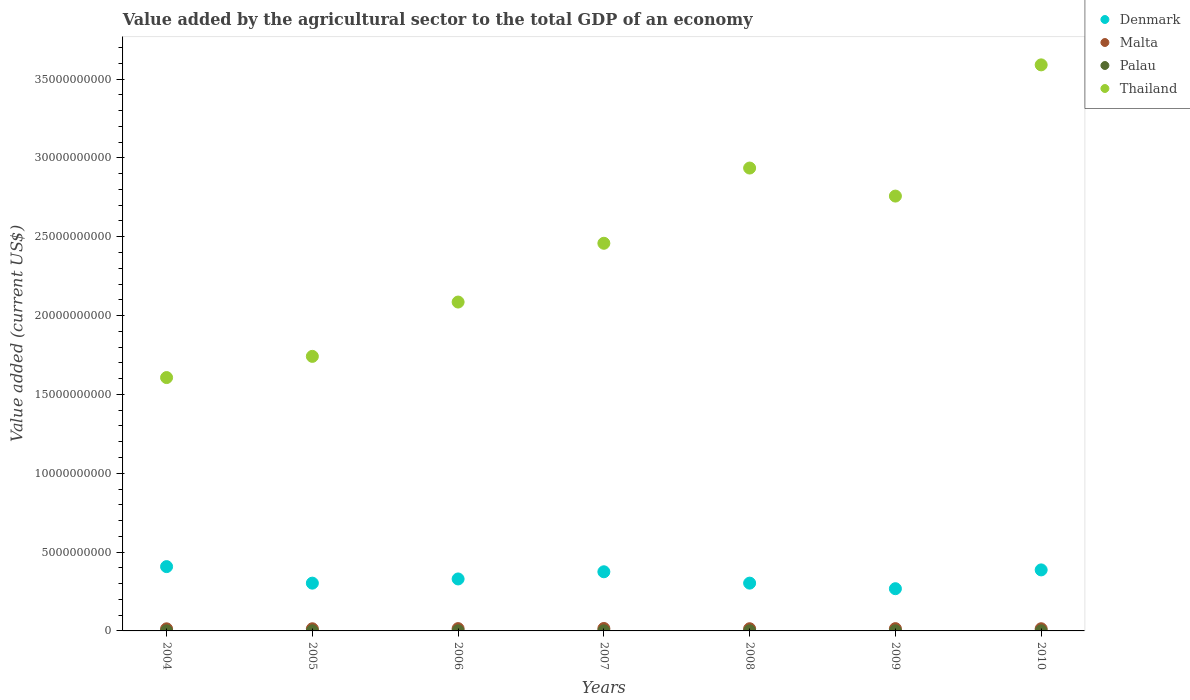How many different coloured dotlines are there?
Offer a very short reply. 4. Is the number of dotlines equal to the number of legend labels?
Your response must be concise. Yes. What is the value added by the agricultural sector to the total GDP in Palau in 2005?
Provide a short and direct response. 7.64e+06. Across all years, what is the maximum value added by the agricultural sector to the total GDP in Palau?
Your response must be concise. 8.54e+06. Across all years, what is the minimum value added by the agricultural sector to the total GDP in Denmark?
Offer a very short reply. 2.68e+09. In which year was the value added by the agricultural sector to the total GDP in Malta maximum?
Give a very brief answer. 2007. In which year was the value added by the agricultural sector to the total GDP in Palau minimum?
Ensure brevity in your answer.  2004. What is the total value added by the agricultural sector to the total GDP in Malta in the graph?
Offer a terse response. 9.92e+08. What is the difference between the value added by the agricultural sector to the total GDP in Palau in 2006 and that in 2008?
Offer a very short reply. 7.83e+04. What is the difference between the value added by the agricultural sector to the total GDP in Palau in 2006 and the value added by the agricultural sector to the total GDP in Denmark in 2010?
Your response must be concise. -3.86e+09. What is the average value added by the agricultural sector to the total GDP in Thailand per year?
Offer a very short reply. 2.45e+1. In the year 2005, what is the difference between the value added by the agricultural sector to the total GDP in Palau and value added by the agricultural sector to the total GDP in Denmark?
Provide a succinct answer. -3.02e+09. In how many years, is the value added by the agricultural sector to the total GDP in Palau greater than 34000000000 US$?
Keep it short and to the point. 0. What is the ratio of the value added by the agricultural sector to the total GDP in Thailand in 2006 to that in 2007?
Ensure brevity in your answer.  0.85. Is the value added by the agricultural sector to the total GDP in Denmark in 2007 less than that in 2009?
Make the answer very short. No. Is the difference between the value added by the agricultural sector to the total GDP in Palau in 2009 and 2010 greater than the difference between the value added by the agricultural sector to the total GDP in Denmark in 2009 and 2010?
Give a very brief answer. Yes. What is the difference between the highest and the second highest value added by the agricultural sector to the total GDP in Thailand?
Your answer should be compact. 6.54e+09. What is the difference between the highest and the lowest value added by the agricultural sector to the total GDP in Malta?
Your answer should be compact. 2.16e+07. In how many years, is the value added by the agricultural sector to the total GDP in Malta greater than the average value added by the agricultural sector to the total GDP in Malta taken over all years?
Provide a short and direct response. 3. Is the sum of the value added by the agricultural sector to the total GDP in Malta in 2006 and 2010 greater than the maximum value added by the agricultural sector to the total GDP in Thailand across all years?
Offer a terse response. No. Is it the case that in every year, the sum of the value added by the agricultural sector to the total GDP in Thailand and value added by the agricultural sector to the total GDP in Denmark  is greater than the sum of value added by the agricultural sector to the total GDP in Malta and value added by the agricultural sector to the total GDP in Palau?
Provide a succinct answer. Yes. Is the value added by the agricultural sector to the total GDP in Denmark strictly greater than the value added by the agricultural sector to the total GDP in Thailand over the years?
Your answer should be very brief. No. Is the value added by the agricultural sector to the total GDP in Malta strictly less than the value added by the agricultural sector to the total GDP in Palau over the years?
Offer a terse response. No. How many years are there in the graph?
Your response must be concise. 7. Are the values on the major ticks of Y-axis written in scientific E-notation?
Your answer should be compact. No. Does the graph contain any zero values?
Offer a terse response. No. How are the legend labels stacked?
Provide a short and direct response. Vertical. What is the title of the graph?
Provide a short and direct response. Value added by the agricultural sector to the total GDP of an economy. Does "Turkmenistan" appear as one of the legend labels in the graph?
Keep it short and to the point. No. What is the label or title of the Y-axis?
Ensure brevity in your answer.  Value added (current US$). What is the Value added (current US$) in Denmark in 2004?
Keep it short and to the point. 4.08e+09. What is the Value added (current US$) in Malta in 2004?
Your answer should be very brief. 1.33e+08. What is the Value added (current US$) of Palau in 2004?
Give a very brief answer. 6.77e+06. What is the Value added (current US$) of Thailand in 2004?
Provide a succinct answer. 1.61e+1. What is the Value added (current US$) in Denmark in 2005?
Offer a terse response. 3.03e+09. What is the Value added (current US$) of Malta in 2005?
Provide a succinct answer. 1.36e+08. What is the Value added (current US$) in Palau in 2005?
Make the answer very short. 7.64e+06. What is the Value added (current US$) in Thailand in 2005?
Provide a short and direct response. 1.74e+1. What is the Value added (current US$) of Denmark in 2006?
Ensure brevity in your answer.  3.30e+09. What is the Value added (current US$) in Malta in 2006?
Ensure brevity in your answer.  1.47e+08. What is the Value added (current US$) of Palau in 2006?
Offer a very short reply. 8.54e+06. What is the Value added (current US$) in Thailand in 2006?
Provide a succinct answer. 2.09e+1. What is the Value added (current US$) of Denmark in 2007?
Your response must be concise. 3.75e+09. What is the Value added (current US$) of Malta in 2007?
Provide a succinct answer. 1.55e+08. What is the Value added (current US$) of Palau in 2007?
Offer a very short reply. 7.87e+06. What is the Value added (current US$) of Thailand in 2007?
Your response must be concise. 2.46e+1. What is the Value added (current US$) of Denmark in 2008?
Offer a very short reply. 3.03e+09. What is the Value added (current US$) in Malta in 2008?
Your answer should be compact. 1.39e+08. What is the Value added (current US$) in Palau in 2008?
Offer a very short reply. 8.46e+06. What is the Value added (current US$) of Thailand in 2008?
Provide a short and direct response. 2.94e+1. What is the Value added (current US$) of Denmark in 2009?
Keep it short and to the point. 2.68e+09. What is the Value added (current US$) in Malta in 2009?
Provide a short and direct response. 1.45e+08. What is the Value added (current US$) in Palau in 2009?
Your answer should be very brief. 7.90e+06. What is the Value added (current US$) in Thailand in 2009?
Offer a very short reply. 2.76e+1. What is the Value added (current US$) in Denmark in 2010?
Offer a very short reply. 3.87e+09. What is the Value added (current US$) in Malta in 2010?
Provide a succinct answer. 1.38e+08. What is the Value added (current US$) in Palau in 2010?
Ensure brevity in your answer.  7.58e+06. What is the Value added (current US$) in Thailand in 2010?
Ensure brevity in your answer.  3.59e+1. Across all years, what is the maximum Value added (current US$) in Denmark?
Give a very brief answer. 4.08e+09. Across all years, what is the maximum Value added (current US$) of Malta?
Your response must be concise. 1.55e+08. Across all years, what is the maximum Value added (current US$) of Palau?
Your answer should be very brief. 8.54e+06. Across all years, what is the maximum Value added (current US$) in Thailand?
Your response must be concise. 3.59e+1. Across all years, what is the minimum Value added (current US$) of Denmark?
Provide a succinct answer. 2.68e+09. Across all years, what is the minimum Value added (current US$) of Malta?
Offer a terse response. 1.33e+08. Across all years, what is the minimum Value added (current US$) in Palau?
Keep it short and to the point. 6.77e+06. Across all years, what is the minimum Value added (current US$) in Thailand?
Provide a succinct answer. 1.61e+1. What is the total Value added (current US$) of Denmark in the graph?
Your answer should be very brief. 2.37e+1. What is the total Value added (current US$) in Malta in the graph?
Ensure brevity in your answer.  9.92e+08. What is the total Value added (current US$) in Palau in the graph?
Offer a terse response. 5.48e+07. What is the total Value added (current US$) in Thailand in the graph?
Offer a terse response. 1.72e+11. What is the difference between the Value added (current US$) of Denmark in 2004 and that in 2005?
Provide a short and direct response. 1.05e+09. What is the difference between the Value added (current US$) in Malta in 2004 and that in 2005?
Offer a terse response. -3.15e+06. What is the difference between the Value added (current US$) in Palau in 2004 and that in 2005?
Offer a very short reply. -8.74e+05. What is the difference between the Value added (current US$) of Thailand in 2004 and that in 2005?
Ensure brevity in your answer.  -1.34e+09. What is the difference between the Value added (current US$) of Denmark in 2004 and that in 2006?
Provide a succinct answer. 7.82e+08. What is the difference between the Value added (current US$) in Malta in 2004 and that in 2006?
Provide a short and direct response. -1.37e+07. What is the difference between the Value added (current US$) in Palau in 2004 and that in 2006?
Ensure brevity in your answer.  -1.77e+06. What is the difference between the Value added (current US$) of Thailand in 2004 and that in 2006?
Offer a terse response. -4.79e+09. What is the difference between the Value added (current US$) of Denmark in 2004 and that in 2007?
Your answer should be compact. 3.27e+08. What is the difference between the Value added (current US$) in Malta in 2004 and that in 2007?
Make the answer very short. -2.16e+07. What is the difference between the Value added (current US$) in Palau in 2004 and that in 2007?
Give a very brief answer. -1.10e+06. What is the difference between the Value added (current US$) of Thailand in 2004 and that in 2007?
Ensure brevity in your answer.  -8.52e+09. What is the difference between the Value added (current US$) in Denmark in 2004 and that in 2008?
Your response must be concise. 1.05e+09. What is the difference between the Value added (current US$) of Malta in 2004 and that in 2008?
Your answer should be compact. -5.84e+06. What is the difference between the Value added (current US$) of Palau in 2004 and that in 2008?
Make the answer very short. -1.70e+06. What is the difference between the Value added (current US$) in Thailand in 2004 and that in 2008?
Provide a short and direct response. -1.33e+1. What is the difference between the Value added (current US$) of Denmark in 2004 and that in 2009?
Ensure brevity in your answer.  1.40e+09. What is the difference between the Value added (current US$) in Malta in 2004 and that in 2009?
Make the answer very short. -1.19e+07. What is the difference between the Value added (current US$) of Palau in 2004 and that in 2009?
Keep it short and to the point. -1.13e+06. What is the difference between the Value added (current US$) of Thailand in 2004 and that in 2009?
Keep it short and to the point. -1.15e+1. What is the difference between the Value added (current US$) in Denmark in 2004 and that in 2010?
Make the answer very short. 2.08e+08. What is the difference between the Value added (current US$) of Malta in 2004 and that in 2010?
Your response must be concise. -4.98e+06. What is the difference between the Value added (current US$) of Palau in 2004 and that in 2010?
Your answer should be compact. -8.16e+05. What is the difference between the Value added (current US$) in Thailand in 2004 and that in 2010?
Make the answer very short. -1.98e+1. What is the difference between the Value added (current US$) of Denmark in 2005 and that in 2006?
Provide a succinct answer. -2.66e+08. What is the difference between the Value added (current US$) in Malta in 2005 and that in 2006?
Provide a succinct answer. -1.06e+07. What is the difference between the Value added (current US$) of Palau in 2005 and that in 2006?
Offer a very short reply. -9.01e+05. What is the difference between the Value added (current US$) of Thailand in 2005 and that in 2006?
Your response must be concise. -3.45e+09. What is the difference between the Value added (current US$) in Denmark in 2005 and that in 2007?
Provide a succinct answer. -7.21e+08. What is the difference between the Value added (current US$) of Malta in 2005 and that in 2007?
Keep it short and to the point. -1.85e+07. What is the difference between the Value added (current US$) of Palau in 2005 and that in 2007?
Your answer should be very brief. -2.30e+05. What is the difference between the Value added (current US$) in Thailand in 2005 and that in 2007?
Your answer should be compact. -7.17e+09. What is the difference between the Value added (current US$) in Denmark in 2005 and that in 2008?
Your response must be concise. -1.23e+06. What is the difference between the Value added (current US$) in Malta in 2005 and that in 2008?
Offer a very short reply. -2.69e+06. What is the difference between the Value added (current US$) in Palau in 2005 and that in 2008?
Provide a short and direct response. -8.23e+05. What is the difference between the Value added (current US$) of Thailand in 2005 and that in 2008?
Your response must be concise. -1.19e+1. What is the difference between the Value added (current US$) in Denmark in 2005 and that in 2009?
Provide a succinct answer. 3.52e+08. What is the difference between the Value added (current US$) in Malta in 2005 and that in 2009?
Offer a terse response. -8.72e+06. What is the difference between the Value added (current US$) in Palau in 2005 and that in 2009?
Your answer should be very brief. -2.58e+05. What is the difference between the Value added (current US$) in Thailand in 2005 and that in 2009?
Your answer should be compact. -1.02e+1. What is the difference between the Value added (current US$) of Denmark in 2005 and that in 2010?
Provide a succinct answer. -8.40e+08. What is the difference between the Value added (current US$) in Malta in 2005 and that in 2010?
Give a very brief answer. -1.83e+06. What is the difference between the Value added (current US$) in Palau in 2005 and that in 2010?
Your answer should be compact. 5.74e+04. What is the difference between the Value added (current US$) of Thailand in 2005 and that in 2010?
Keep it short and to the point. -1.85e+1. What is the difference between the Value added (current US$) in Denmark in 2006 and that in 2007?
Your response must be concise. -4.55e+08. What is the difference between the Value added (current US$) in Malta in 2006 and that in 2007?
Provide a short and direct response. -7.88e+06. What is the difference between the Value added (current US$) in Palau in 2006 and that in 2007?
Make the answer very short. 6.71e+05. What is the difference between the Value added (current US$) of Thailand in 2006 and that in 2007?
Provide a succinct answer. -3.73e+09. What is the difference between the Value added (current US$) of Denmark in 2006 and that in 2008?
Provide a succinct answer. 2.65e+08. What is the difference between the Value added (current US$) in Malta in 2006 and that in 2008?
Provide a short and direct response. 7.91e+06. What is the difference between the Value added (current US$) of Palau in 2006 and that in 2008?
Offer a terse response. 7.83e+04. What is the difference between the Value added (current US$) of Thailand in 2006 and that in 2008?
Make the answer very short. -8.50e+09. What is the difference between the Value added (current US$) in Denmark in 2006 and that in 2009?
Make the answer very short. 6.18e+08. What is the difference between the Value added (current US$) in Malta in 2006 and that in 2009?
Provide a short and direct response. 1.88e+06. What is the difference between the Value added (current US$) of Palau in 2006 and that in 2009?
Offer a very short reply. 6.44e+05. What is the difference between the Value added (current US$) in Thailand in 2006 and that in 2009?
Give a very brief answer. -6.72e+09. What is the difference between the Value added (current US$) in Denmark in 2006 and that in 2010?
Your answer should be compact. -5.74e+08. What is the difference between the Value added (current US$) of Malta in 2006 and that in 2010?
Keep it short and to the point. 8.77e+06. What is the difference between the Value added (current US$) of Palau in 2006 and that in 2010?
Offer a very short reply. 9.59e+05. What is the difference between the Value added (current US$) of Thailand in 2006 and that in 2010?
Provide a succinct answer. -1.50e+1. What is the difference between the Value added (current US$) in Denmark in 2007 and that in 2008?
Offer a very short reply. 7.20e+08. What is the difference between the Value added (current US$) of Malta in 2007 and that in 2008?
Offer a terse response. 1.58e+07. What is the difference between the Value added (current US$) in Palau in 2007 and that in 2008?
Provide a short and direct response. -5.93e+05. What is the difference between the Value added (current US$) of Thailand in 2007 and that in 2008?
Provide a succinct answer. -4.77e+09. What is the difference between the Value added (current US$) in Denmark in 2007 and that in 2009?
Make the answer very short. 1.07e+09. What is the difference between the Value added (current US$) of Malta in 2007 and that in 2009?
Provide a short and direct response. 9.77e+06. What is the difference between the Value added (current US$) in Palau in 2007 and that in 2009?
Provide a succinct answer. -2.71e+04. What is the difference between the Value added (current US$) of Thailand in 2007 and that in 2009?
Provide a succinct answer. -2.99e+09. What is the difference between the Value added (current US$) in Denmark in 2007 and that in 2010?
Offer a very short reply. -1.19e+08. What is the difference between the Value added (current US$) in Malta in 2007 and that in 2010?
Your answer should be compact. 1.67e+07. What is the difference between the Value added (current US$) of Palau in 2007 and that in 2010?
Give a very brief answer. 2.88e+05. What is the difference between the Value added (current US$) of Thailand in 2007 and that in 2010?
Keep it short and to the point. -1.13e+1. What is the difference between the Value added (current US$) of Denmark in 2008 and that in 2009?
Your answer should be very brief. 3.53e+08. What is the difference between the Value added (current US$) of Malta in 2008 and that in 2009?
Offer a very short reply. -6.03e+06. What is the difference between the Value added (current US$) in Palau in 2008 and that in 2009?
Make the answer very short. 5.65e+05. What is the difference between the Value added (current US$) in Thailand in 2008 and that in 2009?
Offer a very short reply. 1.78e+09. What is the difference between the Value added (current US$) of Denmark in 2008 and that in 2010?
Offer a very short reply. -8.39e+08. What is the difference between the Value added (current US$) of Malta in 2008 and that in 2010?
Provide a succinct answer. 8.61e+05. What is the difference between the Value added (current US$) in Palau in 2008 and that in 2010?
Make the answer very short. 8.80e+05. What is the difference between the Value added (current US$) in Thailand in 2008 and that in 2010?
Provide a succinct answer. -6.54e+09. What is the difference between the Value added (current US$) of Denmark in 2009 and that in 2010?
Your response must be concise. -1.19e+09. What is the difference between the Value added (current US$) in Malta in 2009 and that in 2010?
Your answer should be compact. 6.89e+06. What is the difference between the Value added (current US$) of Palau in 2009 and that in 2010?
Your answer should be very brief. 3.15e+05. What is the difference between the Value added (current US$) of Thailand in 2009 and that in 2010?
Offer a terse response. -8.32e+09. What is the difference between the Value added (current US$) in Denmark in 2004 and the Value added (current US$) in Malta in 2005?
Offer a very short reply. 3.94e+09. What is the difference between the Value added (current US$) of Denmark in 2004 and the Value added (current US$) of Palau in 2005?
Make the answer very short. 4.07e+09. What is the difference between the Value added (current US$) in Denmark in 2004 and the Value added (current US$) in Thailand in 2005?
Provide a succinct answer. -1.33e+1. What is the difference between the Value added (current US$) of Malta in 2004 and the Value added (current US$) of Palau in 2005?
Your answer should be very brief. 1.25e+08. What is the difference between the Value added (current US$) in Malta in 2004 and the Value added (current US$) in Thailand in 2005?
Provide a succinct answer. -1.73e+1. What is the difference between the Value added (current US$) in Palau in 2004 and the Value added (current US$) in Thailand in 2005?
Keep it short and to the point. -1.74e+1. What is the difference between the Value added (current US$) of Denmark in 2004 and the Value added (current US$) of Malta in 2006?
Your answer should be compact. 3.93e+09. What is the difference between the Value added (current US$) in Denmark in 2004 and the Value added (current US$) in Palau in 2006?
Provide a succinct answer. 4.07e+09. What is the difference between the Value added (current US$) in Denmark in 2004 and the Value added (current US$) in Thailand in 2006?
Your answer should be very brief. -1.68e+1. What is the difference between the Value added (current US$) of Malta in 2004 and the Value added (current US$) of Palau in 2006?
Your answer should be very brief. 1.24e+08. What is the difference between the Value added (current US$) of Malta in 2004 and the Value added (current US$) of Thailand in 2006?
Provide a succinct answer. -2.07e+1. What is the difference between the Value added (current US$) in Palau in 2004 and the Value added (current US$) in Thailand in 2006?
Ensure brevity in your answer.  -2.09e+1. What is the difference between the Value added (current US$) in Denmark in 2004 and the Value added (current US$) in Malta in 2007?
Your answer should be compact. 3.92e+09. What is the difference between the Value added (current US$) of Denmark in 2004 and the Value added (current US$) of Palau in 2007?
Ensure brevity in your answer.  4.07e+09. What is the difference between the Value added (current US$) of Denmark in 2004 and the Value added (current US$) of Thailand in 2007?
Make the answer very short. -2.05e+1. What is the difference between the Value added (current US$) of Malta in 2004 and the Value added (current US$) of Palau in 2007?
Offer a terse response. 1.25e+08. What is the difference between the Value added (current US$) of Malta in 2004 and the Value added (current US$) of Thailand in 2007?
Provide a short and direct response. -2.45e+1. What is the difference between the Value added (current US$) of Palau in 2004 and the Value added (current US$) of Thailand in 2007?
Make the answer very short. -2.46e+1. What is the difference between the Value added (current US$) of Denmark in 2004 and the Value added (current US$) of Malta in 2008?
Offer a terse response. 3.94e+09. What is the difference between the Value added (current US$) in Denmark in 2004 and the Value added (current US$) in Palau in 2008?
Give a very brief answer. 4.07e+09. What is the difference between the Value added (current US$) in Denmark in 2004 and the Value added (current US$) in Thailand in 2008?
Give a very brief answer. -2.53e+1. What is the difference between the Value added (current US$) of Malta in 2004 and the Value added (current US$) of Palau in 2008?
Your answer should be very brief. 1.25e+08. What is the difference between the Value added (current US$) of Malta in 2004 and the Value added (current US$) of Thailand in 2008?
Your response must be concise. -2.92e+1. What is the difference between the Value added (current US$) of Palau in 2004 and the Value added (current US$) of Thailand in 2008?
Offer a terse response. -2.94e+1. What is the difference between the Value added (current US$) in Denmark in 2004 and the Value added (current US$) in Malta in 2009?
Give a very brief answer. 3.93e+09. What is the difference between the Value added (current US$) in Denmark in 2004 and the Value added (current US$) in Palau in 2009?
Your answer should be compact. 4.07e+09. What is the difference between the Value added (current US$) in Denmark in 2004 and the Value added (current US$) in Thailand in 2009?
Your response must be concise. -2.35e+1. What is the difference between the Value added (current US$) of Malta in 2004 and the Value added (current US$) of Palau in 2009?
Keep it short and to the point. 1.25e+08. What is the difference between the Value added (current US$) in Malta in 2004 and the Value added (current US$) in Thailand in 2009?
Provide a succinct answer. -2.74e+1. What is the difference between the Value added (current US$) in Palau in 2004 and the Value added (current US$) in Thailand in 2009?
Offer a very short reply. -2.76e+1. What is the difference between the Value added (current US$) in Denmark in 2004 and the Value added (current US$) in Malta in 2010?
Keep it short and to the point. 3.94e+09. What is the difference between the Value added (current US$) of Denmark in 2004 and the Value added (current US$) of Palau in 2010?
Keep it short and to the point. 4.07e+09. What is the difference between the Value added (current US$) of Denmark in 2004 and the Value added (current US$) of Thailand in 2010?
Your answer should be very brief. -3.18e+1. What is the difference between the Value added (current US$) in Malta in 2004 and the Value added (current US$) in Palau in 2010?
Your answer should be compact. 1.25e+08. What is the difference between the Value added (current US$) of Malta in 2004 and the Value added (current US$) of Thailand in 2010?
Offer a terse response. -3.58e+1. What is the difference between the Value added (current US$) in Palau in 2004 and the Value added (current US$) in Thailand in 2010?
Your answer should be very brief. -3.59e+1. What is the difference between the Value added (current US$) of Denmark in 2005 and the Value added (current US$) of Malta in 2006?
Your answer should be very brief. 2.88e+09. What is the difference between the Value added (current US$) of Denmark in 2005 and the Value added (current US$) of Palau in 2006?
Provide a short and direct response. 3.02e+09. What is the difference between the Value added (current US$) in Denmark in 2005 and the Value added (current US$) in Thailand in 2006?
Your answer should be very brief. -1.78e+1. What is the difference between the Value added (current US$) in Malta in 2005 and the Value added (current US$) in Palau in 2006?
Keep it short and to the point. 1.28e+08. What is the difference between the Value added (current US$) in Malta in 2005 and the Value added (current US$) in Thailand in 2006?
Your response must be concise. -2.07e+1. What is the difference between the Value added (current US$) of Palau in 2005 and the Value added (current US$) of Thailand in 2006?
Keep it short and to the point. -2.09e+1. What is the difference between the Value added (current US$) in Denmark in 2005 and the Value added (current US$) in Malta in 2007?
Keep it short and to the point. 2.88e+09. What is the difference between the Value added (current US$) in Denmark in 2005 and the Value added (current US$) in Palau in 2007?
Offer a very short reply. 3.02e+09. What is the difference between the Value added (current US$) of Denmark in 2005 and the Value added (current US$) of Thailand in 2007?
Provide a succinct answer. -2.16e+1. What is the difference between the Value added (current US$) of Malta in 2005 and the Value added (current US$) of Palau in 2007?
Make the answer very short. 1.28e+08. What is the difference between the Value added (current US$) of Malta in 2005 and the Value added (current US$) of Thailand in 2007?
Offer a very short reply. -2.45e+1. What is the difference between the Value added (current US$) in Palau in 2005 and the Value added (current US$) in Thailand in 2007?
Your answer should be very brief. -2.46e+1. What is the difference between the Value added (current US$) in Denmark in 2005 and the Value added (current US$) in Malta in 2008?
Make the answer very short. 2.89e+09. What is the difference between the Value added (current US$) of Denmark in 2005 and the Value added (current US$) of Palau in 2008?
Offer a terse response. 3.02e+09. What is the difference between the Value added (current US$) of Denmark in 2005 and the Value added (current US$) of Thailand in 2008?
Provide a short and direct response. -2.63e+1. What is the difference between the Value added (current US$) of Malta in 2005 and the Value added (current US$) of Palau in 2008?
Ensure brevity in your answer.  1.28e+08. What is the difference between the Value added (current US$) in Malta in 2005 and the Value added (current US$) in Thailand in 2008?
Make the answer very short. -2.92e+1. What is the difference between the Value added (current US$) in Palau in 2005 and the Value added (current US$) in Thailand in 2008?
Provide a short and direct response. -2.94e+1. What is the difference between the Value added (current US$) of Denmark in 2005 and the Value added (current US$) of Malta in 2009?
Ensure brevity in your answer.  2.89e+09. What is the difference between the Value added (current US$) of Denmark in 2005 and the Value added (current US$) of Palau in 2009?
Offer a terse response. 3.02e+09. What is the difference between the Value added (current US$) of Denmark in 2005 and the Value added (current US$) of Thailand in 2009?
Ensure brevity in your answer.  -2.46e+1. What is the difference between the Value added (current US$) of Malta in 2005 and the Value added (current US$) of Palau in 2009?
Provide a succinct answer. 1.28e+08. What is the difference between the Value added (current US$) in Malta in 2005 and the Value added (current US$) in Thailand in 2009?
Your answer should be very brief. -2.74e+1. What is the difference between the Value added (current US$) of Palau in 2005 and the Value added (current US$) of Thailand in 2009?
Offer a terse response. -2.76e+1. What is the difference between the Value added (current US$) of Denmark in 2005 and the Value added (current US$) of Malta in 2010?
Offer a very short reply. 2.89e+09. What is the difference between the Value added (current US$) in Denmark in 2005 and the Value added (current US$) in Palau in 2010?
Provide a succinct answer. 3.02e+09. What is the difference between the Value added (current US$) of Denmark in 2005 and the Value added (current US$) of Thailand in 2010?
Provide a succinct answer. -3.29e+1. What is the difference between the Value added (current US$) in Malta in 2005 and the Value added (current US$) in Palau in 2010?
Give a very brief answer. 1.29e+08. What is the difference between the Value added (current US$) of Malta in 2005 and the Value added (current US$) of Thailand in 2010?
Provide a short and direct response. -3.58e+1. What is the difference between the Value added (current US$) of Palau in 2005 and the Value added (current US$) of Thailand in 2010?
Offer a very short reply. -3.59e+1. What is the difference between the Value added (current US$) of Denmark in 2006 and the Value added (current US$) of Malta in 2007?
Provide a succinct answer. 3.14e+09. What is the difference between the Value added (current US$) in Denmark in 2006 and the Value added (current US$) in Palau in 2007?
Offer a very short reply. 3.29e+09. What is the difference between the Value added (current US$) in Denmark in 2006 and the Value added (current US$) in Thailand in 2007?
Offer a very short reply. -2.13e+1. What is the difference between the Value added (current US$) in Malta in 2006 and the Value added (current US$) in Palau in 2007?
Ensure brevity in your answer.  1.39e+08. What is the difference between the Value added (current US$) of Malta in 2006 and the Value added (current US$) of Thailand in 2007?
Offer a very short reply. -2.44e+1. What is the difference between the Value added (current US$) in Palau in 2006 and the Value added (current US$) in Thailand in 2007?
Give a very brief answer. -2.46e+1. What is the difference between the Value added (current US$) in Denmark in 2006 and the Value added (current US$) in Malta in 2008?
Provide a short and direct response. 3.16e+09. What is the difference between the Value added (current US$) in Denmark in 2006 and the Value added (current US$) in Palau in 2008?
Ensure brevity in your answer.  3.29e+09. What is the difference between the Value added (current US$) of Denmark in 2006 and the Value added (current US$) of Thailand in 2008?
Ensure brevity in your answer.  -2.61e+1. What is the difference between the Value added (current US$) of Malta in 2006 and the Value added (current US$) of Palau in 2008?
Provide a succinct answer. 1.38e+08. What is the difference between the Value added (current US$) in Malta in 2006 and the Value added (current US$) in Thailand in 2008?
Make the answer very short. -2.92e+1. What is the difference between the Value added (current US$) of Palau in 2006 and the Value added (current US$) of Thailand in 2008?
Ensure brevity in your answer.  -2.93e+1. What is the difference between the Value added (current US$) in Denmark in 2006 and the Value added (current US$) in Malta in 2009?
Give a very brief answer. 3.15e+09. What is the difference between the Value added (current US$) of Denmark in 2006 and the Value added (current US$) of Palau in 2009?
Your response must be concise. 3.29e+09. What is the difference between the Value added (current US$) in Denmark in 2006 and the Value added (current US$) in Thailand in 2009?
Make the answer very short. -2.43e+1. What is the difference between the Value added (current US$) of Malta in 2006 and the Value added (current US$) of Palau in 2009?
Keep it short and to the point. 1.39e+08. What is the difference between the Value added (current US$) of Malta in 2006 and the Value added (current US$) of Thailand in 2009?
Ensure brevity in your answer.  -2.74e+1. What is the difference between the Value added (current US$) in Palau in 2006 and the Value added (current US$) in Thailand in 2009?
Your answer should be compact. -2.76e+1. What is the difference between the Value added (current US$) of Denmark in 2006 and the Value added (current US$) of Malta in 2010?
Make the answer very short. 3.16e+09. What is the difference between the Value added (current US$) of Denmark in 2006 and the Value added (current US$) of Palau in 2010?
Offer a very short reply. 3.29e+09. What is the difference between the Value added (current US$) of Denmark in 2006 and the Value added (current US$) of Thailand in 2010?
Offer a terse response. -3.26e+1. What is the difference between the Value added (current US$) in Malta in 2006 and the Value added (current US$) in Palau in 2010?
Your response must be concise. 1.39e+08. What is the difference between the Value added (current US$) in Malta in 2006 and the Value added (current US$) in Thailand in 2010?
Provide a succinct answer. -3.58e+1. What is the difference between the Value added (current US$) of Palau in 2006 and the Value added (current US$) of Thailand in 2010?
Offer a terse response. -3.59e+1. What is the difference between the Value added (current US$) in Denmark in 2007 and the Value added (current US$) in Malta in 2008?
Offer a terse response. 3.61e+09. What is the difference between the Value added (current US$) in Denmark in 2007 and the Value added (current US$) in Palau in 2008?
Provide a short and direct response. 3.74e+09. What is the difference between the Value added (current US$) of Denmark in 2007 and the Value added (current US$) of Thailand in 2008?
Provide a succinct answer. -2.56e+1. What is the difference between the Value added (current US$) of Malta in 2007 and the Value added (current US$) of Palau in 2008?
Ensure brevity in your answer.  1.46e+08. What is the difference between the Value added (current US$) of Malta in 2007 and the Value added (current US$) of Thailand in 2008?
Provide a succinct answer. -2.92e+1. What is the difference between the Value added (current US$) in Palau in 2007 and the Value added (current US$) in Thailand in 2008?
Your response must be concise. -2.94e+1. What is the difference between the Value added (current US$) of Denmark in 2007 and the Value added (current US$) of Malta in 2009?
Offer a terse response. 3.61e+09. What is the difference between the Value added (current US$) in Denmark in 2007 and the Value added (current US$) in Palau in 2009?
Provide a short and direct response. 3.74e+09. What is the difference between the Value added (current US$) of Denmark in 2007 and the Value added (current US$) of Thailand in 2009?
Offer a very short reply. -2.38e+1. What is the difference between the Value added (current US$) in Malta in 2007 and the Value added (current US$) in Palau in 2009?
Your answer should be very brief. 1.47e+08. What is the difference between the Value added (current US$) of Malta in 2007 and the Value added (current US$) of Thailand in 2009?
Make the answer very short. -2.74e+1. What is the difference between the Value added (current US$) of Palau in 2007 and the Value added (current US$) of Thailand in 2009?
Make the answer very short. -2.76e+1. What is the difference between the Value added (current US$) in Denmark in 2007 and the Value added (current US$) in Malta in 2010?
Offer a very short reply. 3.61e+09. What is the difference between the Value added (current US$) of Denmark in 2007 and the Value added (current US$) of Palau in 2010?
Ensure brevity in your answer.  3.74e+09. What is the difference between the Value added (current US$) in Denmark in 2007 and the Value added (current US$) in Thailand in 2010?
Make the answer very short. -3.22e+1. What is the difference between the Value added (current US$) of Malta in 2007 and the Value added (current US$) of Palau in 2010?
Your answer should be compact. 1.47e+08. What is the difference between the Value added (current US$) in Malta in 2007 and the Value added (current US$) in Thailand in 2010?
Your response must be concise. -3.57e+1. What is the difference between the Value added (current US$) in Palau in 2007 and the Value added (current US$) in Thailand in 2010?
Your answer should be very brief. -3.59e+1. What is the difference between the Value added (current US$) of Denmark in 2008 and the Value added (current US$) of Malta in 2009?
Your answer should be very brief. 2.89e+09. What is the difference between the Value added (current US$) in Denmark in 2008 and the Value added (current US$) in Palau in 2009?
Give a very brief answer. 3.02e+09. What is the difference between the Value added (current US$) in Denmark in 2008 and the Value added (current US$) in Thailand in 2009?
Keep it short and to the point. -2.45e+1. What is the difference between the Value added (current US$) in Malta in 2008 and the Value added (current US$) in Palau in 2009?
Your answer should be compact. 1.31e+08. What is the difference between the Value added (current US$) of Malta in 2008 and the Value added (current US$) of Thailand in 2009?
Your answer should be very brief. -2.74e+1. What is the difference between the Value added (current US$) of Palau in 2008 and the Value added (current US$) of Thailand in 2009?
Offer a very short reply. -2.76e+1. What is the difference between the Value added (current US$) in Denmark in 2008 and the Value added (current US$) in Malta in 2010?
Offer a very short reply. 2.89e+09. What is the difference between the Value added (current US$) in Denmark in 2008 and the Value added (current US$) in Palau in 2010?
Offer a terse response. 3.02e+09. What is the difference between the Value added (current US$) in Denmark in 2008 and the Value added (current US$) in Thailand in 2010?
Give a very brief answer. -3.29e+1. What is the difference between the Value added (current US$) of Malta in 2008 and the Value added (current US$) of Palau in 2010?
Your response must be concise. 1.31e+08. What is the difference between the Value added (current US$) of Malta in 2008 and the Value added (current US$) of Thailand in 2010?
Ensure brevity in your answer.  -3.58e+1. What is the difference between the Value added (current US$) of Palau in 2008 and the Value added (current US$) of Thailand in 2010?
Keep it short and to the point. -3.59e+1. What is the difference between the Value added (current US$) of Denmark in 2009 and the Value added (current US$) of Malta in 2010?
Give a very brief answer. 2.54e+09. What is the difference between the Value added (current US$) of Denmark in 2009 and the Value added (current US$) of Palau in 2010?
Your response must be concise. 2.67e+09. What is the difference between the Value added (current US$) of Denmark in 2009 and the Value added (current US$) of Thailand in 2010?
Your response must be concise. -3.32e+1. What is the difference between the Value added (current US$) of Malta in 2009 and the Value added (current US$) of Palau in 2010?
Keep it short and to the point. 1.37e+08. What is the difference between the Value added (current US$) of Malta in 2009 and the Value added (current US$) of Thailand in 2010?
Make the answer very short. -3.58e+1. What is the difference between the Value added (current US$) of Palau in 2009 and the Value added (current US$) of Thailand in 2010?
Your response must be concise. -3.59e+1. What is the average Value added (current US$) of Denmark per year?
Provide a succinct answer. 3.39e+09. What is the average Value added (current US$) of Malta per year?
Offer a terse response. 1.42e+08. What is the average Value added (current US$) of Palau per year?
Your response must be concise. 7.82e+06. What is the average Value added (current US$) in Thailand per year?
Your response must be concise. 2.45e+1. In the year 2004, what is the difference between the Value added (current US$) in Denmark and Value added (current US$) in Malta?
Make the answer very short. 3.95e+09. In the year 2004, what is the difference between the Value added (current US$) in Denmark and Value added (current US$) in Palau?
Make the answer very short. 4.07e+09. In the year 2004, what is the difference between the Value added (current US$) of Denmark and Value added (current US$) of Thailand?
Provide a short and direct response. -1.20e+1. In the year 2004, what is the difference between the Value added (current US$) of Malta and Value added (current US$) of Palau?
Offer a terse response. 1.26e+08. In the year 2004, what is the difference between the Value added (current US$) in Malta and Value added (current US$) in Thailand?
Provide a succinct answer. -1.59e+1. In the year 2004, what is the difference between the Value added (current US$) of Palau and Value added (current US$) of Thailand?
Provide a short and direct response. -1.61e+1. In the year 2005, what is the difference between the Value added (current US$) of Denmark and Value added (current US$) of Malta?
Make the answer very short. 2.89e+09. In the year 2005, what is the difference between the Value added (current US$) in Denmark and Value added (current US$) in Palau?
Keep it short and to the point. 3.02e+09. In the year 2005, what is the difference between the Value added (current US$) of Denmark and Value added (current US$) of Thailand?
Offer a very short reply. -1.44e+1. In the year 2005, what is the difference between the Value added (current US$) of Malta and Value added (current US$) of Palau?
Give a very brief answer. 1.29e+08. In the year 2005, what is the difference between the Value added (current US$) of Malta and Value added (current US$) of Thailand?
Offer a terse response. -1.73e+1. In the year 2005, what is the difference between the Value added (current US$) in Palau and Value added (current US$) in Thailand?
Provide a succinct answer. -1.74e+1. In the year 2006, what is the difference between the Value added (current US$) in Denmark and Value added (current US$) in Malta?
Provide a short and direct response. 3.15e+09. In the year 2006, what is the difference between the Value added (current US$) of Denmark and Value added (current US$) of Palau?
Your response must be concise. 3.29e+09. In the year 2006, what is the difference between the Value added (current US$) of Denmark and Value added (current US$) of Thailand?
Offer a terse response. -1.76e+1. In the year 2006, what is the difference between the Value added (current US$) of Malta and Value added (current US$) of Palau?
Your answer should be very brief. 1.38e+08. In the year 2006, what is the difference between the Value added (current US$) in Malta and Value added (current US$) in Thailand?
Ensure brevity in your answer.  -2.07e+1. In the year 2006, what is the difference between the Value added (current US$) in Palau and Value added (current US$) in Thailand?
Your response must be concise. -2.09e+1. In the year 2007, what is the difference between the Value added (current US$) in Denmark and Value added (current US$) in Malta?
Give a very brief answer. 3.60e+09. In the year 2007, what is the difference between the Value added (current US$) in Denmark and Value added (current US$) in Palau?
Keep it short and to the point. 3.74e+09. In the year 2007, what is the difference between the Value added (current US$) of Denmark and Value added (current US$) of Thailand?
Keep it short and to the point. -2.08e+1. In the year 2007, what is the difference between the Value added (current US$) of Malta and Value added (current US$) of Palau?
Your answer should be compact. 1.47e+08. In the year 2007, what is the difference between the Value added (current US$) in Malta and Value added (current US$) in Thailand?
Your response must be concise. -2.44e+1. In the year 2007, what is the difference between the Value added (current US$) of Palau and Value added (current US$) of Thailand?
Provide a short and direct response. -2.46e+1. In the year 2008, what is the difference between the Value added (current US$) of Denmark and Value added (current US$) of Malta?
Provide a succinct answer. 2.89e+09. In the year 2008, what is the difference between the Value added (current US$) of Denmark and Value added (current US$) of Palau?
Your answer should be compact. 3.02e+09. In the year 2008, what is the difference between the Value added (current US$) of Denmark and Value added (current US$) of Thailand?
Keep it short and to the point. -2.63e+1. In the year 2008, what is the difference between the Value added (current US$) in Malta and Value added (current US$) in Palau?
Offer a terse response. 1.30e+08. In the year 2008, what is the difference between the Value added (current US$) of Malta and Value added (current US$) of Thailand?
Offer a very short reply. -2.92e+1. In the year 2008, what is the difference between the Value added (current US$) in Palau and Value added (current US$) in Thailand?
Offer a very short reply. -2.93e+1. In the year 2009, what is the difference between the Value added (current US$) of Denmark and Value added (current US$) of Malta?
Your answer should be compact. 2.53e+09. In the year 2009, what is the difference between the Value added (current US$) in Denmark and Value added (current US$) in Palau?
Provide a succinct answer. 2.67e+09. In the year 2009, what is the difference between the Value added (current US$) in Denmark and Value added (current US$) in Thailand?
Make the answer very short. -2.49e+1. In the year 2009, what is the difference between the Value added (current US$) in Malta and Value added (current US$) in Palau?
Offer a terse response. 1.37e+08. In the year 2009, what is the difference between the Value added (current US$) in Malta and Value added (current US$) in Thailand?
Keep it short and to the point. -2.74e+1. In the year 2009, what is the difference between the Value added (current US$) in Palau and Value added (current US$) in Thailand?
Your answer should be compact. -2.76e+1. In the year 2010, what is the difference between the Value added (current US$) in Denmark and Value added (current US$) in Malta?
Offer a very short reply. 3.73e+09. In the year 2010, what is the difference between the Value added (current US$) in Denmark and Value added (current US$) in Palau?
Keep it short and to the point. 3.86e+09. In the year 2010, what is the difference between the Value added (current US$) in Denmark and Value added (current US$) in Thailand?
Keep it short and to the point. -3.20e+1. In the year 2010, what is the difference between the Value added (current US$) in Malta and Value added (current US$) in Palau?
Make the answer very short. 1.30e+08. In the year 2010, what is the difference between the Value added (current US$) of Malta and Value added (current US$) of Thailand?
Offer a terse response. -3.58e+1. In the year 2010, what is the difference between the Value added (current US$) in Palau and Value added (current US$) in Thailand?
Provide a short and direct response. -3.59e+1. What is the ratio of the Value added (current US$) in Denmark in 2004 to that in 2005?
Make the answer very short. 1.35. What is the ratio of the Value added (current US$) of Malta in 2004 to that in 2005?
Offer a terse response. 0.98. What is the ratio of the Value added (current US$) in Palau in 2004 to that in 2005?
Provide a short and direct response. 0.89. What is the ratio of the Value added (current US$) of Thailand in 2004 to that in 2005?
Offer a terse response. 0.92. What is the ratio of the Value added (current US$) of Denmark in 2004 to that in 2006?
Offer a terse response. 1.24. What is the ratio of the Value added (current US$) of Malta in 2004 to that in 2006?
Keep it short and to the point. 0.91. What is the ratio of the Value added (current US$) of Palau in 2004 to that in 2006?
Your answer should be very brief. 0.79. What is the ratio of the Value added (current US$) of Thailand in 2004 to that in 2006?
Give a very brief answer. 0.77. What is the ratio of the Value added (current US$) of Denmark in 2004 to that in 2007?
Your answer should be compact. 1.09. What is the ratio of the Value added (current US$) of Malta in 2004 to that in 2007?
Keep it short and to the point. 0.86. What is the ratio of the Value added (current US$) in Palau in 2004 to that in 2007?
Your answer should be compact. 0.86. What is the ratio of the Value added (current US$) of Thailand in 2004 to that in 2007?
Your answer should be compact. 0.65. What is the ratio of the Value added (current US$) in Denmark in 2004 to that in 2008?
Your answer should be compact. 1.35. What is the ratio of the Value added (current US$) of Malta in 2004 to that in 2008?
Keep it short and to the point. 0.96. What is the ratio of the Value added (current US$) of Palau in 2004 to that in 2008?
Ensure brevity in your answer.  0.8. What is the ratio of the Value added (current US$) in Thailand in 2004 to that in 2008?
Give a very brief answer. 0.55. What is the ratio of the Value added (current US$) in Denmark in 2004 to that in 2009?
Provide a succinct answer. 1.52. What is the ratio of the Value added (current US$) in Malta in 2004 to that in 2009?
Give a very brief answer. 0.92. What is the ratio of the Value added (current US$) in Palau in 2004 to that in 2009?
Your response must be concise. 0.86. What is the ratio of the Value added (current US$) in Thailand in 2004 to that in 2009?
Keep it short and to the point. 0.58. What is the ratio of the Value added (current US$) of Denmark in 2004 to that in 2010?
Offer a very short reply. 1.05. What is the ratio of the Value added (current US$) of Malta in 2004 to that in 2010?
Your answer should be very brief. 0.96. What is the ratio of the Value added (current US$) of Palau in 2004 to that in 2010?
Your answer should be very brief. 0.89. What is the ratio of the Value added (current US$) of Thailand in 2004 to that in 2010?
Your answer should be compact. 0.45. What is the ratio of the Value added (current US$) in Denmark in 2005 to that in 2006?
Keep it short and to the point. 0.92. What is the ratio of the Value added (current US$) in Malta in 2005 to that in 2006?
Offer a very short reply. 0.93. What is the ratio of the Value added (current US$) of Palau in 2005 to that in 2006?
Your answer should be very brief. 0.89. What is the ratio of the Value added (current US$) in Thailand in 2005 to that in 2006?
Your response must be concise. 0.83. What is the ratio of the Value added (current US$) of Denmark in 2005 to that in 2007?
Make the answer very short. 0.81. What is the ratio of the Value added (current US$) of Malta in 2005 to that in 2007?
Offer a terse response. 0.88. What is the ratio of the Value added (current US$) of Palau in 2005 to that in 2007?
Provide a short and direct response. 0.97. What is the ratio of the Value added (current US$) in Thailand in 2005 to that in 2007?
Your answer should be very brief. 0.71. What is the ratio of the Value added (current US$) in Denmark in 2005 to that in 2008?
Your answer should be compact. 1. What is the ratio of the Value added (current US$) in Malta in 2005 to that in 2008?
Ensure brevity in your answer.  0.98. What is the ratio of the Value added (current US$) in Palau in 2005 to that in 2008?
Offer a very short reply. 0.9. What is the ratio of the Value added (current US$) of Thailand in 2005 to that in 2008?
Make the answer very short. 0.59. What is the ratio of the Value added (current US$) in Denmark in 2005 to that in 2009?
Provide a succinct answer. 1.13. What is the ratio of the Value added (current US$) in Malta in 2005 to that in 2009?
Your answer should be very brief. 0.94. What is the ratio of the Value added (current US$) of Palau in 2005 to that in 2009?
Offer a terse response. 0.97. What is the ratio of the Value added (current US$) of Thailand in 2005 to that in 2009?
Your answer should be compact. 0.63. What is the ratio of the Value added (current US$) in Denmark in 2005 to that in 2010?
Your answer should be very brief. 0.78. What is the ratio of the Value added (current US$) in Malta in 2005 to that in 2010?
Keep it short and to the point. 0.99. What is the ratio of the Value added (current US$) in Palau in 2005 to that in 2010?
Offer a terse response. 1.01. What is the ratio of the Value added (current US$) of Thailand in 2005 to that in 2010?
Your response must be concise. 0.48. What is the ratio of the Value added (current US$) of Denmark in 2006 to that in 2007?
Your answer should be compact. 0.88. What is the ratio of the Value added (current US$) in Malta in 2006 to that in 2007?
Offer a terse response. 0.95. What is the ratio of the Value added (current US$) in Palau in 2006 to that in 2007?
Provide a short and direct response. 1.09. What is the ratio of the Value added (current US$) of Thailand in 2006 to that in 2007?
Your answer should be compact. 0.85. What is the ratio of the Value added (current US$) in Denmark in 2006 to that in 2008?
Your response must be concise. 1.09. What is the ratio of the Value added (current US$) in Malta in 2006 to that in 2008?
Give a very brief answer. 1.06. What is the ratio of the Value added (current US$) of Palau in 2006 to that in 2008?
Ensure brevity in your answer.  1.01. What is the ratio of the Value added (current US$) in Thailand in 2006 to that in 2008?
Provide a short and direct response. 0.71. What is the ratio of the Value added (current US$) in Denmark in 2006 to that in 2009?
Ensure brevity in your answer.  1.23. What is the ratio of the Value added (current US$) of Malta in 2006 to that in 2009?
Offer a very short reply. 1.01. What is the ratio of the Value added (current US$) of Palau in 2006 to that in 2009?
Provide a succinct answer. 1.08. What is the ratio of the Value added (current US$) in Thailand in 2006 to that in 2009?
Keep it short and to the point. 0.76. What is the ratio of the Value added (current US$) of Denmark in 2006 to that in 2010?
Offer a very short reply. 0.85. What is the ratio of the Value added (current US$) of Malta in 2006 to that in 2010?
Provide a succinct answer. 1.06. What is the ratio of the Value added (current US$) of Palau in 2006 to that in 2010?
Your answer should be very brief. 1.13. What is the ratio of the Value added (current US$) of Thailand in 2006 to that in 2010?
Ensure brevity in your answer.  0.58. What is the ratio of the Value added (current US$) in Denmark in 2007 to that in 2008?
Your response must be concise. 1.24. What is the ratio of the Value added (current US$) in Malta in 2007 to that in 2008?
Your answer should be very brief. 1.11. What is the ratio of the Value added (current US$) in Thailand in 2007 to that in 2008?
Your response must be concise. 0.84. What is the ratio of the Value added (current US$) of Denmark in 2007 to that in 2009?
Provide a succinct answer. 1.4. What is the ratio of the Value added (current US$) of Malta in 2007 to that in 2009?
Provide a short and direct response. 1.07. What is the ratio of the Value added (current US$) in Palau in 2007 to that in 2009?
Your response must be concise. 1. What is the ratio of the Value added (current US$) in Thailand in 2007 to that in 2009?
Provide a succinct answer. 0.89. What is the ratio of the Value added (current US$) of Denmark in 2007 to that in 2010?
Offer a terse response. 0.97. What is the ratio of the Value added (current US$) in Malta in 2007 to that in 2010?
Your response must be concise. 1.12. What is the ratio of the Value added (current US$) in Palau in 2007 to that in 2010?
Your answer should be very brief. 1.04. What is the ratio of the Value added (current US$) in Thailand in 2007 to that in 2010?
Your answer should be compact. 0.68. What is the ratio of the Value added (current US$) of Denmark in 2008 to that in 2009?
Give a very brief answer. 1.13. What is the ratio of the Value added (current US$) in Malta in 2008 to that in 2009?
Your answer should be very brief. 0.96. What is the ratio of the Value added (current US$) of Palau in 2008 to that in 2009?
Offer a very short reply. 1.07. What is the ratio of the Value added (current US$) in Thailand in 2008 to that in 2009?
Offer a terse response. 1.06. What is the ratio of the Value added (current US$) of Denmark in 2008 to that in 2010?
Ensure brevity in your answer.  0.78. What is the ratio of the Value added (current US$) of Palau in 2008 to that in 2010?
Your answer should be very brief. 1.12. What is the ratio of the Value added (current US$) in Thailand in 2008 to that in 2010?
Provide a succinct answer. 0.82. What is the ratio of the Value added (current US$) in Denmark in 2009 to that in 2010?
Make the answer very short. 0.69. What is the ratio of the Value added (current US$) in Malta in 2009 to that in 2010?
Keep it short and to the point. 1.05. What is the ratio of the Value added (current US$) in Palau in 2009 to that in 2010?
Offer a very short reply. 1.04. What is the ratio of the Value added (current US$) in Thailand in 2009 to that in 2010?
Provide a succinct answer. 0.77. What is the difference between the highest and the second highest Value added (current US$) of Denmark?
Provide a succinct answer. 2.08e+08. What is the difference between the highest and the second highest Value added (current US$) of Malta?
Your answer should be compact. 7.88e+06. What is the difference between the highest and the second highest Value added (current US$) of Palau?
Offer a very short reply. 7.83e+04. What is the difference between the highest and the second highest Value added (current US$) in Thailand?
Offer a terse response. 6.54e+09. What is the difference between the highest and the lowest Value added (current US$) in Denmark?
Provide a short and direct response. 1.40e+09. What is the difference between the highest and the lowest Value added (current US$) of Malta?
Provide a short and direct response. 2.16e+07. What is the difference between the highest and the lowest Value added (current US$) of Palau?
Make the answer very short. 1.77e+06. What is the difference between the highest and the lowest Value added (current US$) in Thailand?
Provide a short and direct response. 1.98e+1. 